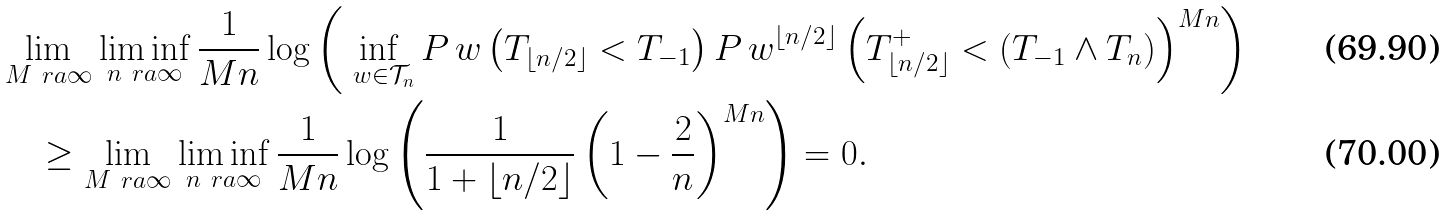Convert formula to latex. <formula><loc_0><loc_0><loc_500><loc_500>& \lim _ { M \ r a \infty } \liminf _ { n \ r a \infty } \frac { 1 } { M n } \log \left ( \inf _ { \ w \in \mathcal { T } _ { n } } P _ { \ } w \left ( T _ { \lfloor n / 2 \rfloor } < T _ { - 1 } \right ) P _ { \ } w ^ { \lfloor n / 2 \rfloor } \left ( T _ { \lfloor n / 2 \rfloor } ^ { + } < ( T _ { - 1 } \wedge T _ { n } ) \right ) ^ { M n } \right ) \\ & \quad \geq \lim _ { M \ r a \infty } \liminf _ { n \ r a \infty } \frac { 1 } { M n } \log \left ( \frac { 1 } { 1 + \lfloor n / 2 \rfloor } \left ( 1 - \frac { 2 } { n } \right ) ^ { M n } \right ) = 0 .</formula> 